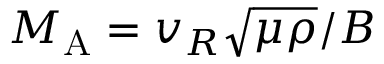Convert formula to latex. <formula><loc_0><loc_0><loc_500><loc_500>M _ { A } = v _ { R } \sqrt { \mu \rho } / B</formula> 